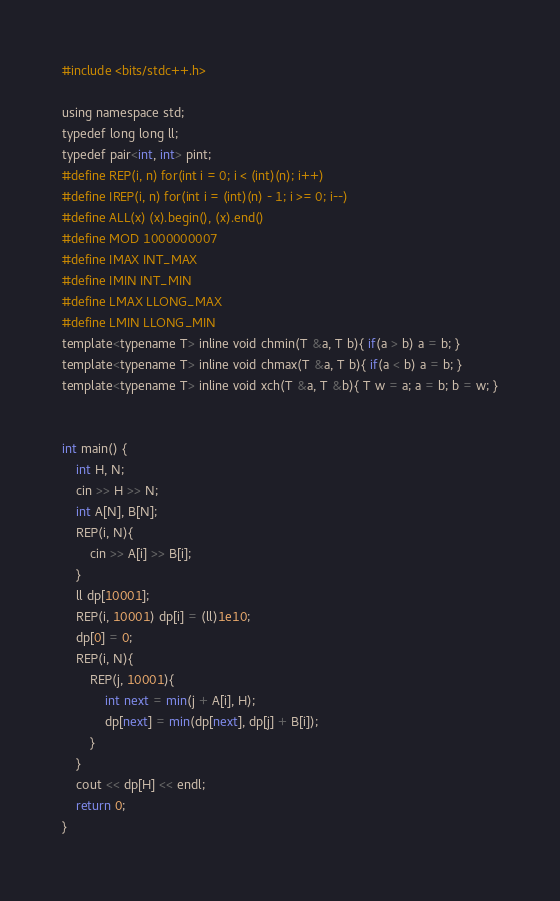Convert code to text. <code><loc_0><loc_0><loc_500><loc_500><_Python_>#include <bits/stdc++.h>

using namespace std;
typedef long long ll;
typedef pair<int, int> pint;
#define REP(i, n) for(int i = 0; i < (int)(n); i++)
#define IREP(i, n) for(int i = (int)(n) - 1; i >= 0; i--)
#define ALL(x) (x).begin(), (x).end()
#define MOD 1000000007
#define IMAX INT_MAX
#define IMIN INT_MIN
#define LMAX LLONG_MAX
#define LMIN LLONG_MIN
template<typename T> inline void chmin(T &a, T b){ if(a > b) a = b; }
template<typename T> inline void chmax(T &a, T b){ if(a < b) a = b; }
template<typename T> inline void xch(T &a, T &b){ T w = a; a = b; b = w; }


int main() {
    int H, N;
    cin >> H >> N;
    int A[N], B[N];
    REP(i, N){
        cin >> A[i] >> B[i];
    }
    ll dp[10001];
    REP(i, 10001) dp[i] = (ll)1e10;
    dp[0] = 0;
    REP(i, N){
        REP(j, 10001){
            int next = min(j + A[i], H);
            dp[next] = min(dp[next], dp[j] + B[i]);
        }
    }
    cout << dp[H] << endl;
    return 0;
}
</code> 